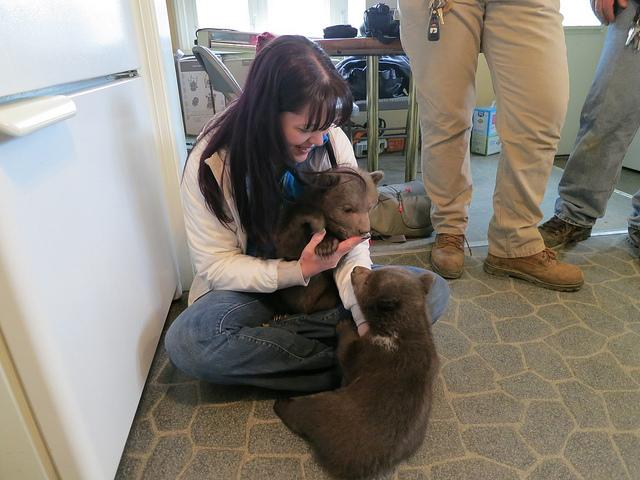What is she sitting next to on the left? Please explain your reasoning. fridge. There is a device with a door. 